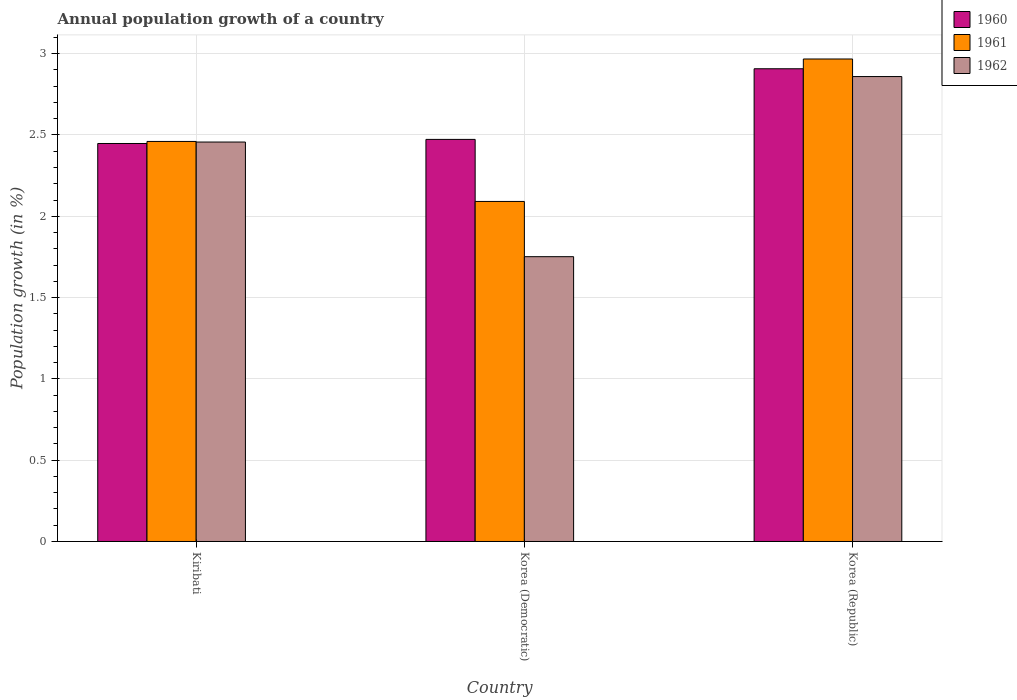Are the number of bars per tick equal to the number of legend labels?
Provide a succinct answer. Yes. How many bars are there on the 3rd tick from the left?
Offer a very short reply. 3. What is the label of the 1st group of bars from the left?
Keep it short and to the point. Kiribati. What is the annual population growth in 1962 in Kiribati?
Make the answer very short. 2.46. Across all countries, what is the maximum annual population growth in 1961?
Provide a succinct answer. 2.97. Across all countries, what is the minimum annual population growth in 1961?
Provide a short and direct response. 2.09. In which country was the annual population growth in 1960 maximum?
Your response must be concise. Korea (Republic). In which country was the annual population growth in 1962 minimum?
Offer a very short reply. Korea (Democratic). What is the total annual population growth in 1960 in the graph?
Your response must be concise. 7.83. What is the difference between the annual population growth in 1960 in Kiribati and that in Korea (Republic)?
Your answer should be compact. -0.46. What is the difference between the annual population growth in 1961 in Kiribati and the annual population growth in 1962 in Korea (Republic)?
Your answer should be very brief. -0.4. What is the average annual population growth in 1960 per country?
Your answer should be compact. 2.61. What is the difference between the annual population growth of/in 1962 and annual population growth of/in 1961 in Kiribati?
Give a very brief answer. -0. In how many countries, is the annual population growth in 1960 greater than 0.1 %?
Offer a very short reply. 3. What is the ratio of the annual population growth in 1961 in Kiribati to that in Korea (Republic)?
Give a very brief answer. 0.83. Is the difference between the annual population growth in 1962 in Korea (Democratic) and Korea (Republic) greater than the difference between the annual population growth in 1961 in Korea (Democratic) and Korea (Republic)?
Provide a succinct answer. No. What is the difference between the highest and the second highest annual population growth in 1962?
Provide a short and direct response. -1.11. What is the difference between the highest and the lowest annual population growth in 1962?
Your answer should be very brief. 1.11. In how many countries, is the annual population growth in 1961 greater than the average annual population growth in 1961 taken over all countries?
Offer a terse response. 1. Is the sum of the annual population growth in 1960 in Kiribati and Korea (Democratic) greater than the maximum annual population growth in 1961 across all countries?
Provide a succinct answer. Yes. What does the 1st bar from the left in Korea (Republic) represents?
Make the answer very short. 1960. Is it the case that in every country, the sum of the annual population growth in 1961 and annual population growth in 1960 is greater than the annual population growth in 1962?
Offer a terse response. Yes. Are all the bars in the graph horizontal?
Your response must be concise. No. How many countries are there in the graph?
Offer a terse response. 3. What is the difference between two consecutive major ticks on the Y-axis?
Your answer should be compact. 0.5. Does the graph contain any zero values?
Your answer should be compact. No. What is the title of the graph?
Keep it short and to the point. Annual population growth of a country. Does "2000" appear as one of the legend labels in the graph?
Give a very brief answer. No. What is the label or title of the Y-axis?
Ensure brevity in your answer.  Population growth (in %). What is the Population growth (in %) of 1960 in Kiribati?
Provide a succinct answer. 2.45. What is the Population growth (in %) in 1961 in Kiribati?
Provide a succinct answer. 2.46. What is the Population growth (in %) of 1962 in Kiribati?
Your answer should be very brief. 2.46. What is the Population growth (in %) of 1960 in Korea (Democratic)?
Provide a short and direct response. 2.47. What is the Population growth (in %) in 1961 in Korea (Democratic)?
Your answer should be very brief. 2.09. What is the Population growth (in %) of 1962 in Korea (Democratic)?
Offer a very short reply. 1.75. What is the Population growth (in %) of 1960 in Korea (Republic)?
Your response must be concise. 2.91. What is the Population growth (in %) of 1961 in Korea (Republic)?
Make the answer very short. 2.97. What is the Population growth (in %) of 1962 in Korea (Republic)?
Your response must be concise. 2.86. Across all countries, what is the maximum Population growth (in %) of 1960?
Provide a succinct answer. 2.91. Across all countries, what is the maximum Population growth (in %) of 1961?
Offer a very short reply. 2.97. Across all countries, what is the maximum Population growth (in %) in 1962?
Your answer should be very brief. 2.86. Across all countries, what is the minimum Population growth (in %) of 1960?
Provide a short and direct response. 2.45. Across all countries, what is the minimum Population growth (in %) of 1961?
Provide a short and direct response. 2.09. Across all countries, what is the minimum Population growth (in %) in 1962?
Your response must be concise. 1.75. What is the total Population growth (in %) in 1960 in the graph?
Ensure brevity in your answer.  7.83. What is the total Population growth (in %) of 1961 in the graph?
Ensure brevity in your answer.  7.52. What is the total Population growth (in %) of 1962 in the graph?
Give a very brief answer. 7.07. What is the difference between the Population growth (in %) in 1960 in Kiribati and that in Korea (Democratic)?
Give a very brief answer. -0.03. What is the difference between the Population growth (in %) in 1961 in Kiribati and that in Korea (Democratic)?
Ensure brevity in your answer.  0.37. What is the difference between the Population growth (in %) in 1962 in Kiribati and that in Korea (Democratic)?
Ensure brevity in your answer.  0.7. What is the difference between the Population growth (in %) of 1960 in Kiribati and that in Korea (Republic)?
Your answer should be compact. -0.46. What is the difference between the Population growth (in %) of 1961 in Kiribati and that in Korea (Republic)?
Your response must be concise. -0.51. What is the difference between the Population growth (in %) in 1962 in Kiribati and that in Korea (Republic)?
Your answer should be compact. -0.4. What is the difference between the Population growth (in %) in 1960 in Korea (Democratic) and that in Korea (Republic)?
Make the answer very short. -0.43. What is the difference between the Population growth (in %) of 1961 in Korea (Democratic) and that in Korea (Republic)?
Your answer should be very brief. -0.88. What is the difference between the Population growth (in %) of 1962 in Korea (Democratic) and that in Korea (Republic)?
Keep it short and to the point. -1.11. What is the difference between the Population growth (in %) in 1960 in Kiribati and the Population growth (in %) in 1961 in Korea (Democratic)?
Offer a terse response. 0.36. What is the difference between the Population growth (in %) in 1960 in Kiribati and the Population growth (in %) in 1962 in Korea (Democratic)?
Give a very brief answer. 0.7. What is the difference between the Population growth (in %) of 1961 in Kiribati and the Population growth (in %) of 1962 in Korea (Democratic)?
Provide a short and direct response. 0.71. What is the difference between the Population growth (in %) of 1960 in Kiribati and the Population growth (in %) of 1961 in Korea (Republic)?
Your answer should be compact. -0.52. What is the difference between the Population growth (in %) in 1960 in Kiribati and the Population growth (in %) in 1962 in Korea (Republic)?
Keep it short and to the point. -0.41. What is the difference between the Population growth (in %) in 1961 in Kiribati and the Population growth (in %) in 1962 in Korea (Republic)?
Provide a short and direct response. -0.4. What is the difference between the Population growth (in %) of 1960 in Korea (Democratic) and the Population growth (in %) of 1961 in Korea (Republic)?
Your answer should be compact. -0.49. What is the difference between the Population growth (in %) of 1960 in Korea (Democratic) and the Population growth (in %) of 1962 in Korea (Republic)?
Your response must be concise. -0.39. What is the difference between the Population growth (in %) of 1961 in Korea (Democratic) and the Population growth (in %) of 1962 in Korea (Republic)?
Your answer should be compact. -0.77. What is the average Population growth (in %) in 1960 per country?
Provide a succinct answer. 2.61. What is the average Population growth (in %) in 1961 per country?
Provide a short and direct response. 2.51. What is the average Population growth (in %) in 1962 per country?
Your answer should be compact. 2.36. What is the difference between the Population growth (in %) of 1960 and Population growth (in %) of 1961 in Kiribati?
Offer a terse response. -0.01. What is the difference between the Population growth (in %) in 1960 and Population growth (in %) in 1962 in Kiribati?
Keep it short and to the point. -0.01. What is the difference between the Population growth (in %) of 1961 and Population growth (in %) of 1962 in Kiribati?
Ensure brevity in your answer.  0. What is the difference between the Population growth (in %) of 1960 and Population growth (in %) of 1961 in Korea (Democratic)?
Your answer should be compact. 0.38. What is the difference between the Population growth (in %) in 1960 and Population growth (in %) in 1962 in Korea (Democratic)?
Offer a very short reply. 0.72. What is the difference between the Population growth (in %) of 1961 and Population growth (in %) of 1962 in Korea (Democratic)?
Your answer should be compact. 0.34. What is the difference between the Population growth (in %) in 1960 and Population growth (in %) in 1961 in Korea (Republic)?
Your answer should be compact. -0.06. What is the difference between the Population growth (in %) of 1960 and Population growth (in %) of 1962 in Korea (Republic)?
Your response must be concise. 0.05. What is the difference between the Population growth (in %) in 1961 and Population growth (in %) in 1962 in Korea (Republic)?
Your answer should be very brief. 0.11. What is the ratio of the Population growth (in %) of 1961 in Kiribati to that in Korea (Democratic)?
Your answer should be compact. 1.18. What is the ratio of the Population growth (in %) of 1962 in Kiribati to that in Korea (Democratic)?
Your answer should be very brief. 1.4. What is the ratio of the Population growth (in %) in 1960 in Kiribati to that in Korea (Republic)?
Your answer should be very brief. 0.84. What is the ratio of the Population growth (in %) in 1961 in Kiribati to that in Korea (Republic)?
Ensure brevity in your answer.  0.83. What is the ratio of the Population growth (in %) of 1962 in Kiribati to that in Korea (Republic)?
Your answer should be very brief. 0.86. What is the ratio of the Population growth (in %) of 1960 in Korea (Democratic) to that in Korea (Republic)?
Your answer should be very brief. 0.85. What is the ratio of the Population growth (in %) in 1961 in Korea (Democratic) to that in Korea (Republic)?
Provide a short and direct response. 0.7. What is the ratio of the Population growth (in %) of 1962 in Korea (Democratic) to that in Korea (Republic)?
Offer a terse response. 0.61. What is the difference between the highest and the second highest Population growth (in %) of 1960?
Keep it short and to the point. 0.43. What is the difference between the highest and the second highest Population growth (in %) of 1961?
Give a very brief answer. 0.51. What is the difference between the highest and the second highest Population growth (in %) in 1962?
Make the answer very short. 0.4. What is the difference between the highest and the lowest Population growth (in %) in 1960?
Offer a terse response. 0.46. What is the difference between the highest and the lowest Population growth (in %) in 1961?
Your answer should be compact. 0.88. What is the difference between the highest and the lowest Population growth (in %) in 1962?
Your answer should be very brief. 1.11. 